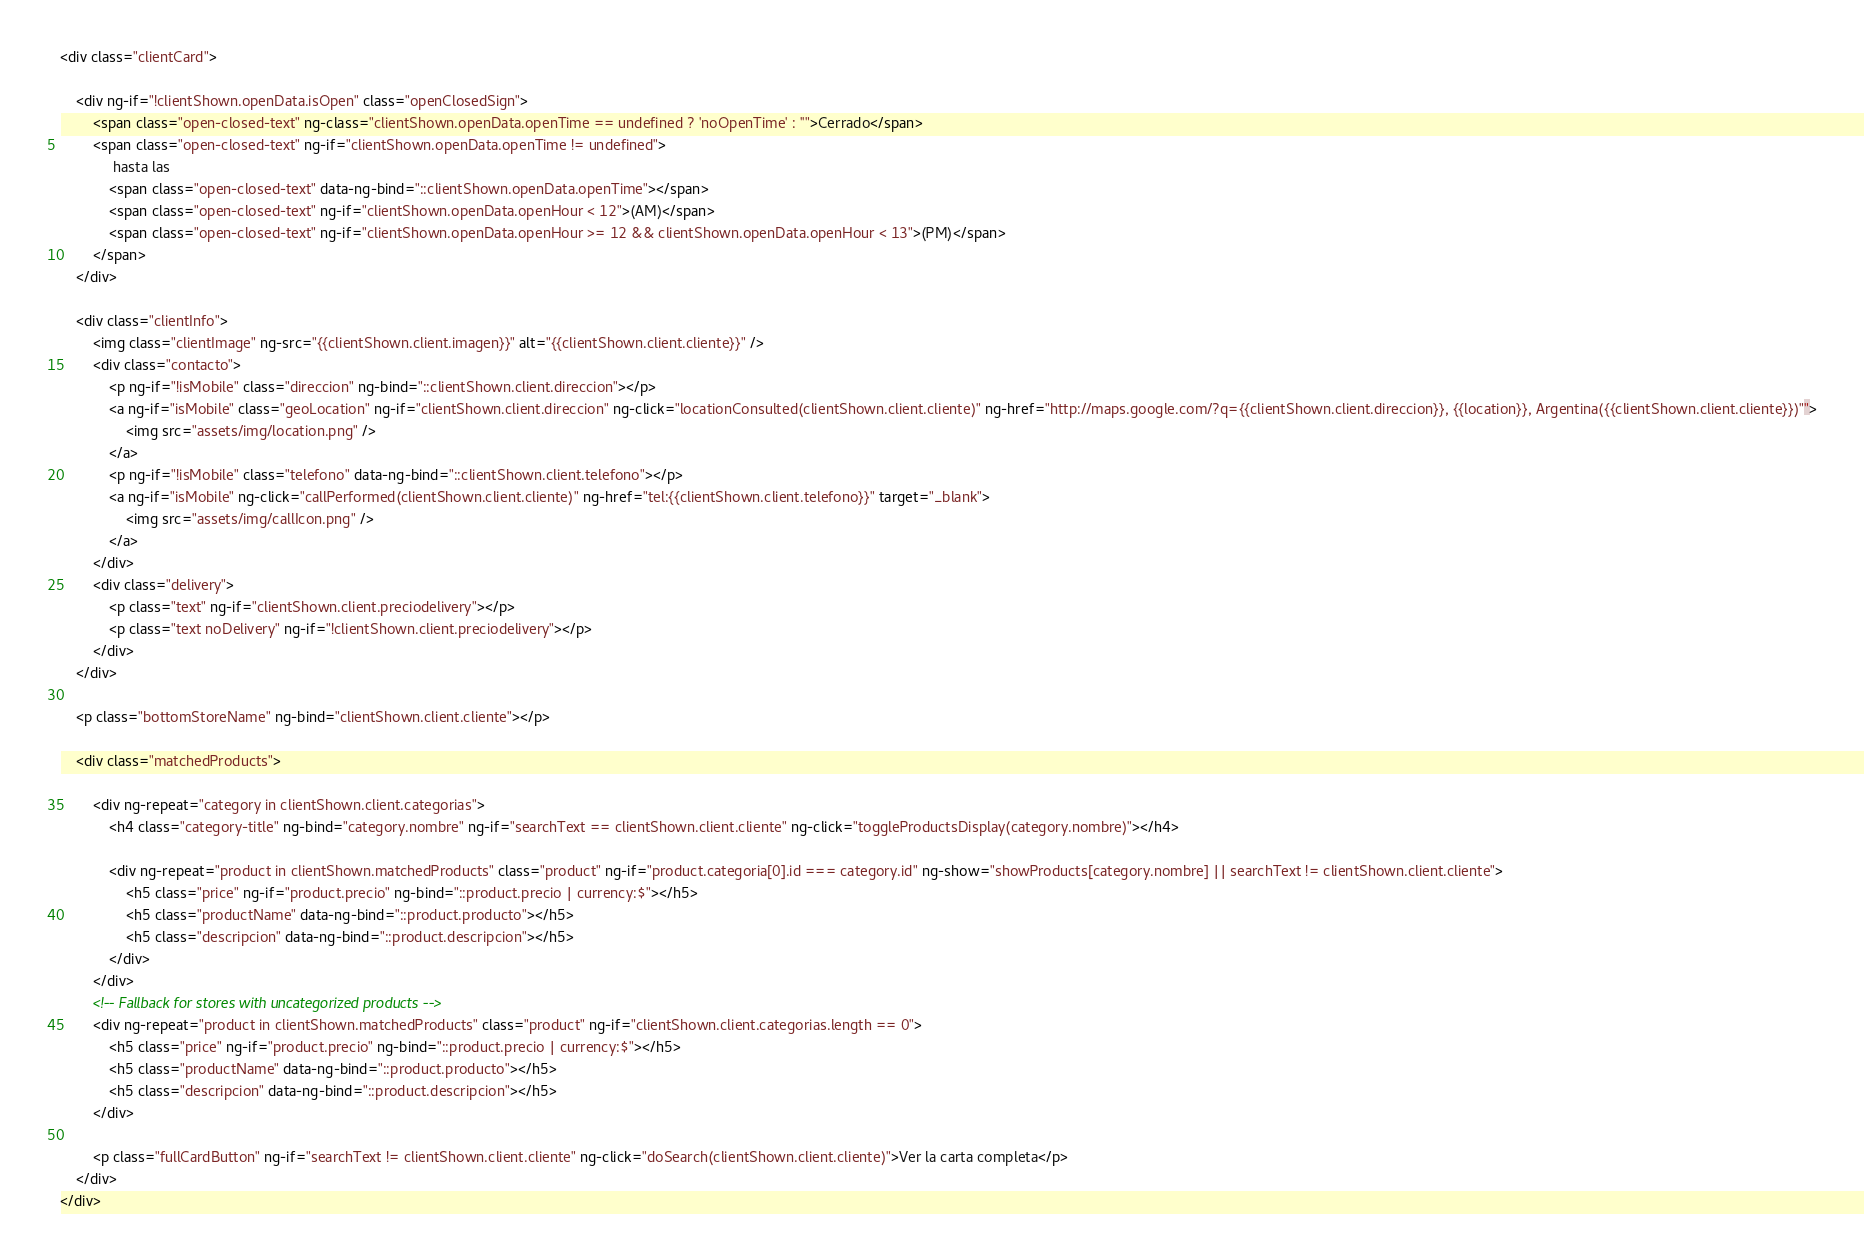<code> <loc_0><loc_0><loc_500><loc_500><_HTML_><div class="clientCard">

    <div ng-if="!clientShown.openData.isOpen" class="openClosedSign">
        <span class="open-closed-text" ng-class="clientShown.openData.openTime == undefined ? 'noOpenTime' : ''">Cerrado</span>
        <span class="open-closed-text" ng-if="clientShown.openData.openTime != undefined">
             hasta las 
            <span class="open-closed-text" data-ng-bind="::clientShown.openData.openTime"></span>
            <span class="open-closed-text" ng-if="clientShown.openData.openHour < 12">(AM)</span>
            <span class="open-closed-text" ng-if="clientShown.openData.openHour >= 12 && clientShown.openData.openHour < 13">(PM)</span>
        </span>
    </div>

    <div class="clientInfo">
        <img class="clientImage" ng-src="{{clientShown.client.imagen}}" alt="{{clientShown.client.cliente}}" />
        <div class="contacto">
            <p ng-if="!isMobile" class="direccion" ng-bind="::clientShown.client.direccion"></p>
            <a ng-if="isMobile" class="geoLocation" ng-if="clientShown.client.direccion" ng-click="locationConsulted(clientShown.client.cliente)" ng-href="http://maps.google.com/?q={{clientShown.client.direccion}}, {{location}}, Argentina({{clientShown.client.cliente}})"">
                <img src="assets/img/location.png" />
            </a>
            <p ng-if="!isMobile" class="telefono" data-ng-bind="::clientShown.client.telefono"></p>
            <a ng-if="isMobile" ng-click="callPerformed(clientShown.client.cliente)" ng-href="tel:{{clientShown.client.telefono}}" target="_blank">
                <img src="assets/img/callIcon.png" />
            </a>
        </div>
        <div class="delivery">
            <p class="text" ng-if="clientShown.client.preciodelivery"></p>
            <p class="text noDelivery" ng-if="!clientShown.client.preciodelivery"></p>
        </div>
    </div>

    <p class="bottomStoreName" ng-bind="clientShown.client.cliente"></p>

    <div class="matchedProducts">

        <div ng-repeat="category in clientShown.client.categorias">
            <h4 class="category-title" ng-bind="category.nombre" ng-if="searchText == clientShown.client.cliente" ng-click="toggleProductsDisplay(category.nombre)"></h4>

            <div ng-repeat="product in clientShown.matchedProducts" class="product" ng-if="product.categoria[0].id === category.id" ng-show="showProducts[category.nombre] || searchText != clientShown.client.cliente">
                <h5 class="price" ng-if="product.precio" ng-bind="::product.precio | currency:$"></h5>
                <h5 class="productName" data-ng-bind="::product.producto"></h5>
                <h5 class="descripcion" data-ng-bind="::product.descripcion"></h5>
            </div>
        </div>
        <!-- Fallback for stores with uncategorized products -->
        <div ng-repeat="product in clientShown.matchedProducts" class="product" ng-if="clientShown.client.categorias.length == 0">
            <h5 class="price" ng-if="product.precio" ng-bind="::product.precio | currency:$"></h5>
            <h5 class="productName" data-ng-bind="::product.producto"></h5>
            <h5 class="descripcion" data-ng-bind="::product.descripcion"></h5>
        </div>

        <p class="fullCardButton" ng-if="searchText != clientShown.client.cliente" ng-click="doSearch(clientShown.client.cliente)">Ver la carta completa</p>
    </div>
</div></code> 